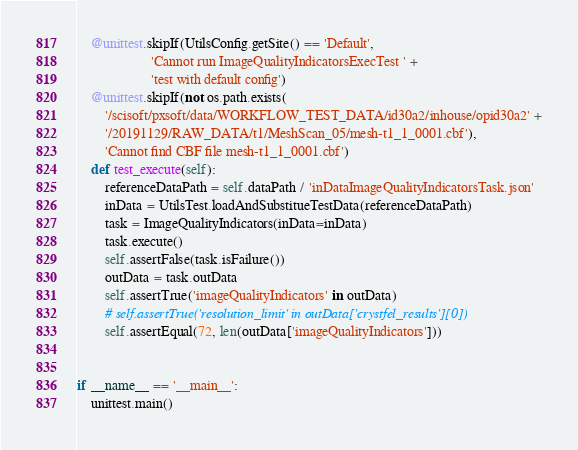Convert code to text. <code><loc_0><loc_0><loc_500><loc_500><_Python_>    @unittest.skipIf(UtilsConfig.getSite() == 'Default',
                     'Cannot run ImageQualityIndicatorsExecTest ' +
                     'test with default config')
    @unittest.skipIf(not os.path.exists(
        '/scisoft/pxsoft/data/WORKFLOW_TEST_DATA/id30a2/inhouse/opid30a2' +
        '/20191129/RAW_DATA/t1/MeshScan_05/mesh-t1_1_0001.cbf'),
        'Cannot find CBF file mesh-t1_1_0001.cbf')
    def test_execute(self):
        referenceDataPath = self.dataPath / 'inDataImageQualityIndicatorsTask.json'
        inData = UtilsTest.loadAndSubstitueTestData(referenceDataPath)
        task = ImageQualityIndicators(inData=inData)
        task.execute()
        self.assertFalse(task.isFailure())
        outData = task.outData
        self.assertTrue('imageQualityIndicators' in outData)
        # self.assertTrue('resolution_limit' in outData['crystfel_results'][0])
        self.assertEqual(72, len(outData['imageQualityIndicators']))


if __name__ == '__main__':
    unittest.main()</code> 